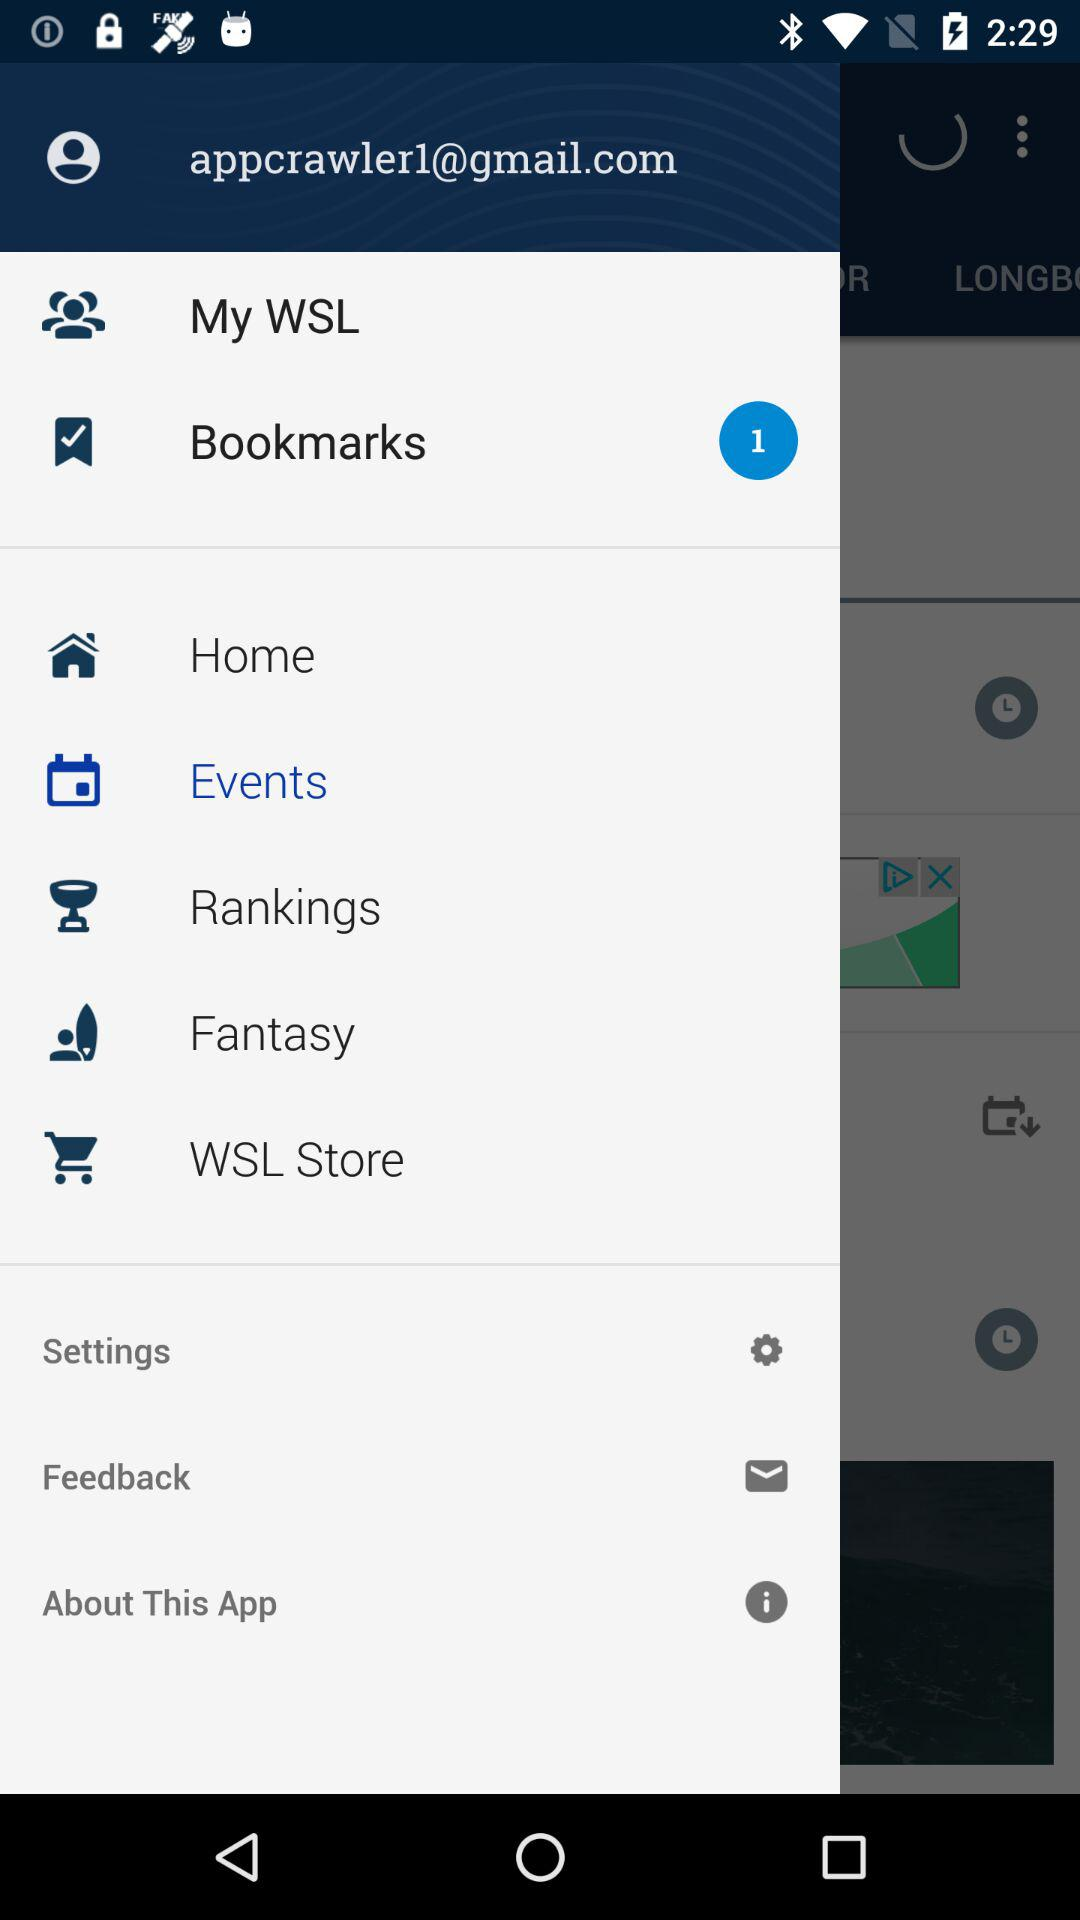How many new notifications are there in the "Bookmarks"? There is 1 new notification. 